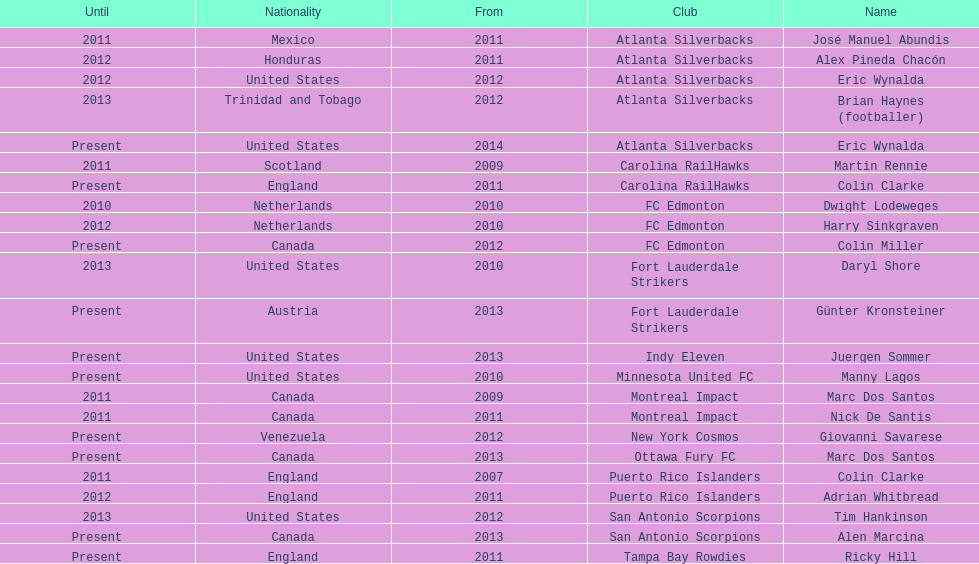What name is listed at the top? José Manuel Abundis. 